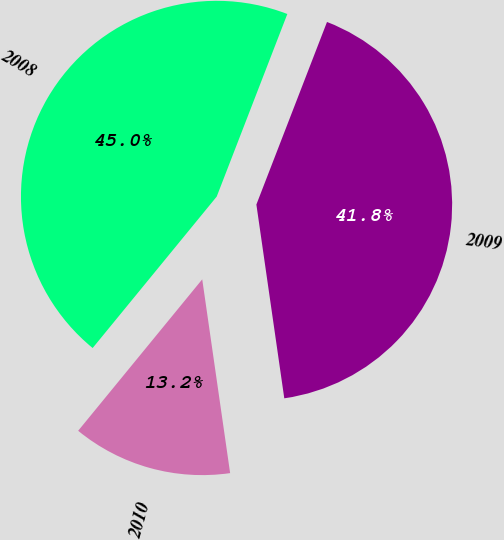Convert chart to OTSL. <chart><loc_0><loc_0><loc_500><loc_500><pie_chart><fcel>2008<fcel>2009<fcel>2010<nl><fcel>44.95%<fcel>41.85%<fcel>13.2%<nl></chart> 